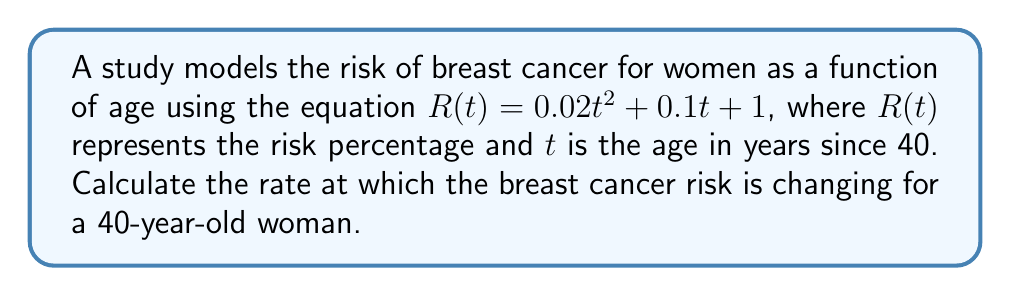Can you solve this math problem? To find the rate at which the breast cancer risk is changing, we need to calculate the derivative of the risk function $R(t)$ and evaluate it at $t=0$ (since the age is measured in years since 40, and we're interested in a 40-year-old woman).

Step 1: Find the derivative of $R(t)$
$$R(t) = 0.02t^2 + 0.1t + 1$$
$$R'(t) = \frac{d}{dt}(0.02t^2 + 0.1t + 1)$$
$$R'(t) = 0.04t + 0.1$$

Step 2: Evaluate $R'(t)$ at $t=0$
$$R'(0) = 0.04(0) + 0.1 = 0.1$$

Therefore, the rate at which the breast cancer risk is changing for a 40-year-old woman is 0.1 percentage points per year.
Answer: 0.1 percentage points per year 